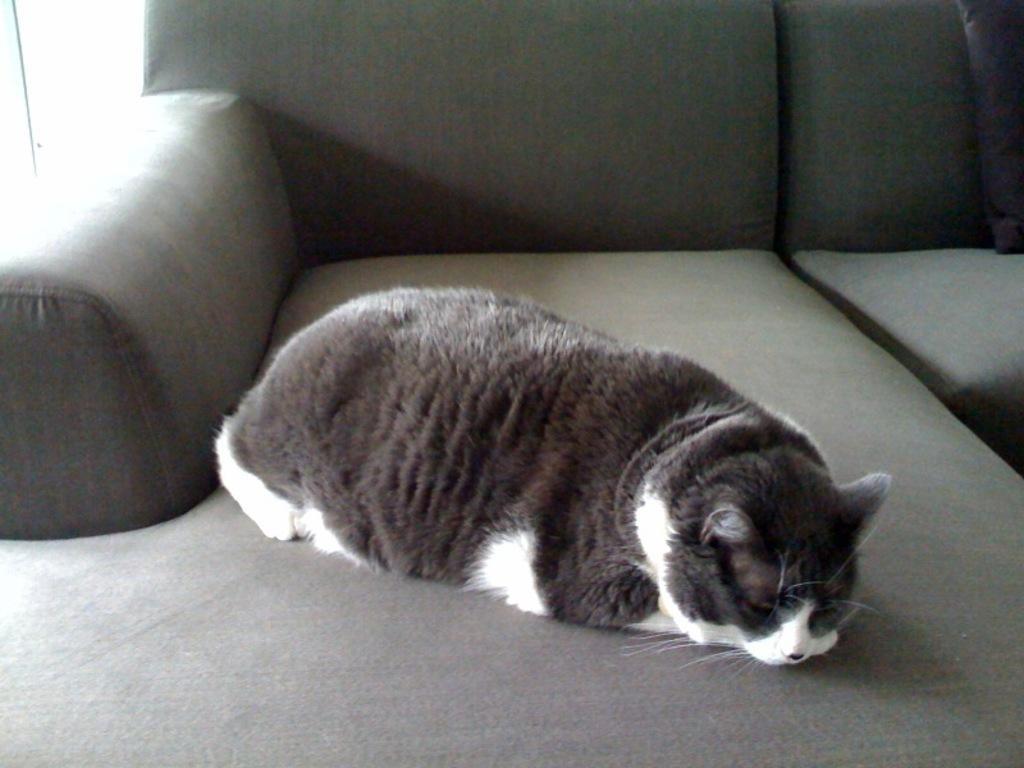In one or two sentences, can you explain what this image depicts? In the picture we can see a sofa on it we can see a cat is sleeping which is black and some part white in color. 